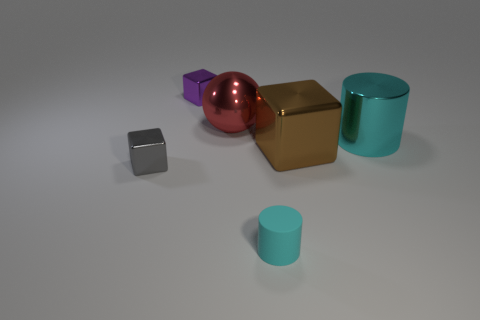Subtract all big brown cubes. How many cubes are left? 2 Add 1 large brown cylinders. How many objects exist? 7 Subtract all gray cubes. How many cubes are left? 2 Subtract all yellow cylinders. Subtract all blue balls. How many cylinders are left? 2 Subtract all yellow spheres. How many green blocks are left? 0 Subtract all cyan balls. Subtract all brown metallic cubes. How many objects are left? 5 Add 5 purple shiny objects. How many purple shiny objects are left? 6 Add 5 tiny red metal cubes. How many tiny red metal cubes exist? 5 Subtract 0 brown cylinders. How many objects are left? 6 Subtract all cylinders. How many objects are left? 4 